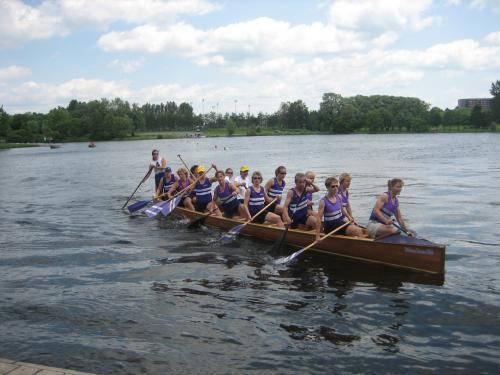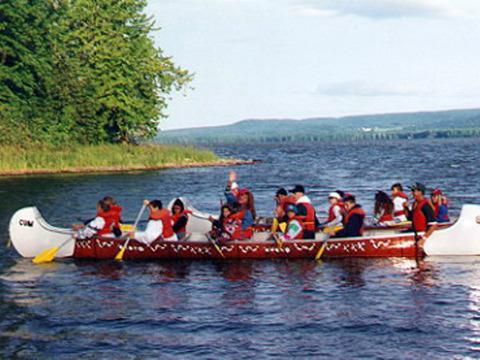The first image is the image on the left, the second image is the image on the right. Examine the images to the left and right. Is the description "One of the boats is red." accurate? Answer yes or no. Yes. The first image is the image on the left, the second image is the image on the right. Assess this claim about the two images: "In 1 of the images, the oars are kicking up spray.". Correct or not? Answer yes or no. No. 